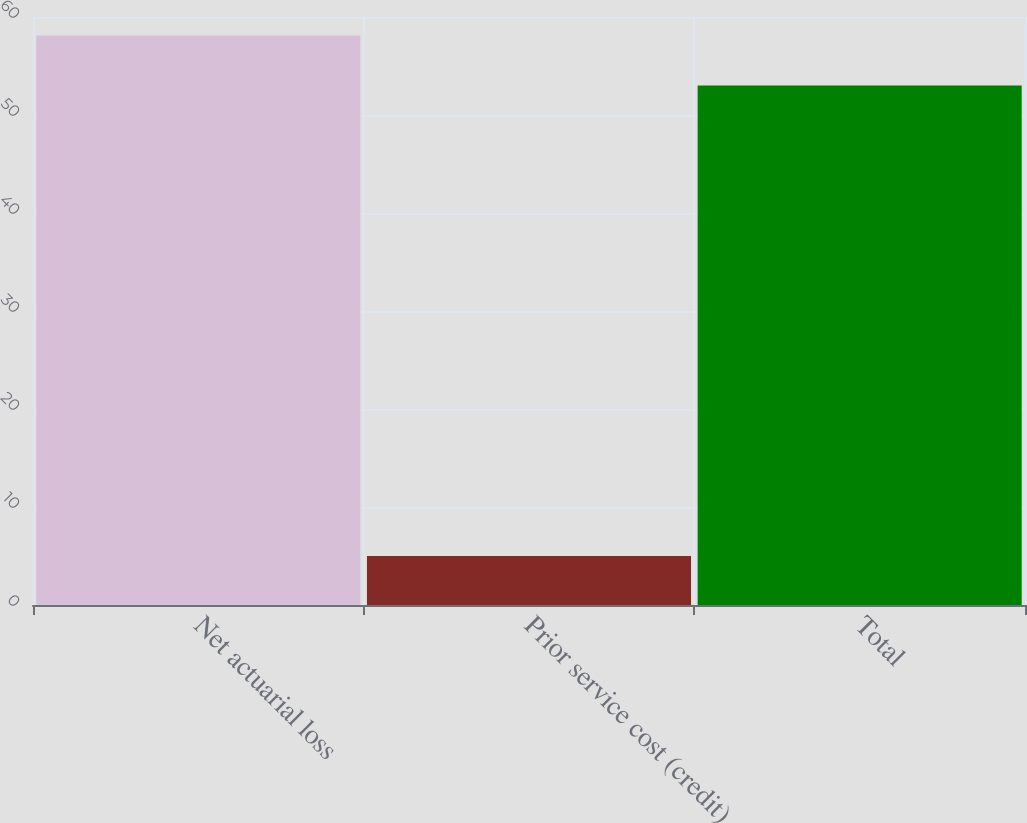Convert chart to OTSL. <chart><loc_0><loc_0><loc_500><loc_500><bar_chart><fcel>Net actuarial loss<fcel>Prior service cost (credit)<fcel>Total<nl><fcel>58.1<fcel>5<fcel>53<nl></chart> 